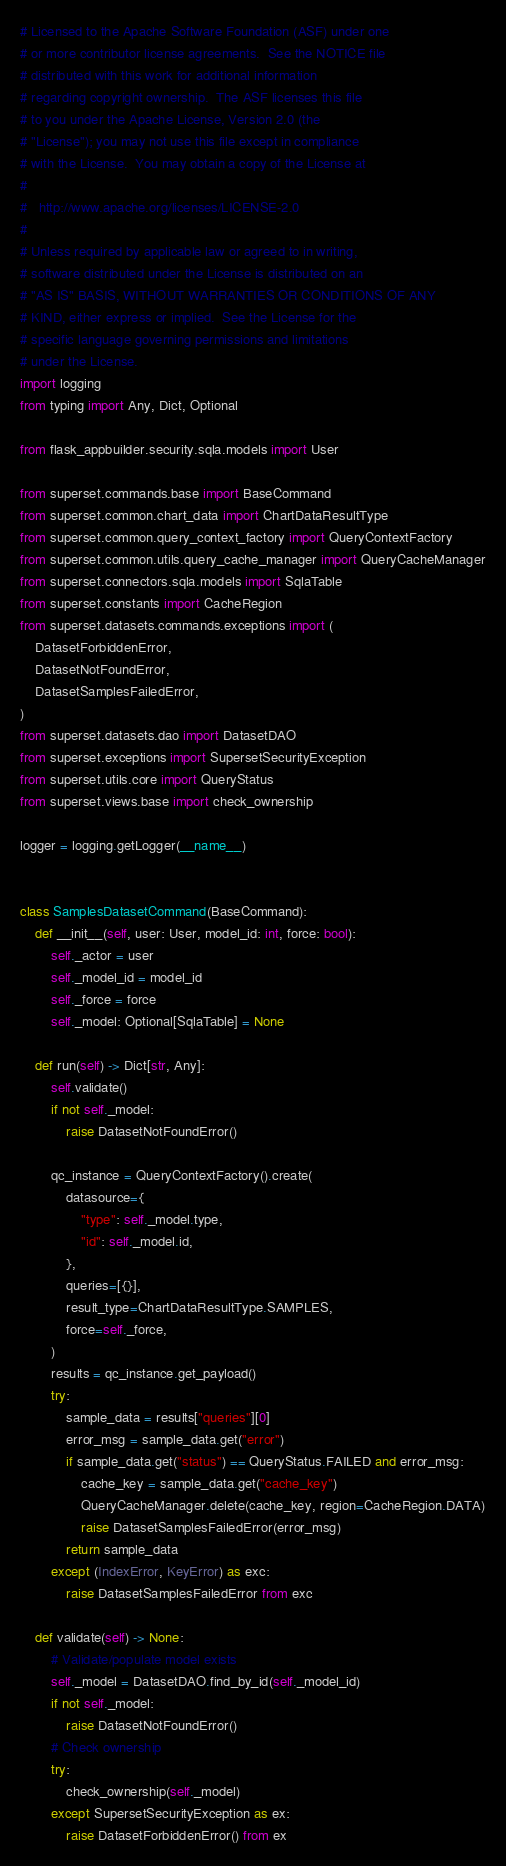Convert code to text. <code><loc_0><loc_0><loc_500><loc_500><_Python_># Licensed to the Apache Software Foundation (ASF) under one
# or more contributor license agreements.  See the NOTICE file
# distributed with this work for additional information
# regarding copyright ownership.  The ASF licenses this file
# to you under the Apache License, Version 2.0 (the
# "License"); you may not use this file except in compliance
# with the License.  You may obtain a copy of the License at
#
#   http://www.apache.org/licenses/LICENSE-2.0
#
# Unless required by applicable law or agreed to in writing,
# software distributed under the License is distributed on an
# "AS IS" BASIS, WITHOUT WARRANTIES OR CONDITIONS OF ANY
# KIND, either express or implied.  See the License for the
# specific language governing permissions and limitations
# under the License.
import logging
from typing import Any, Dict, Optional

from flask_appbuilder.security.sqla.models import User

from superset.commands.base import BaseCommand
from superset.common.chart_data import ChartDataResultType
from superset.common.query_context_factory import QueryContextFactory
from superset.common.utils.query_cache_manager import QueryCacheManager
from superset.connectors.sqla.models import SqlaTable
from superset.constants import CacheRegion
from superset.datasets.commands.exceptions import (
    DatasetForbiddenError,
    DatasetNotFoundError,
    DatasetSamplesFailedError,
)
from superset.datasets.dao import DatasetDAO
from superset.exceptions import SupersetSecurityException
from superset.utils.core import QueryStatus
from superset.views.base import check_ownership

logger = logging.getLogger(__name__)


class SamplesDatasetCommand(BaseCommand):
    def __init__(self, user: User, model_id: int, force: bool):
        self._actor = user
        self._model_id = model_id
        self._force = force
        self._model: Optional[SqlaTable] = None

    def run(self) -> Dict[str, Any]:
        self.validate()
        if not self._model:
            raise DatasetNotFoundError()

        qc_instance = QueryContextFactory().create(
            datasource={
                "type": self._model.type,
                "id": self._model.id,
            },
            queries=[{}],
            result_type=ChartDataResultType.SAMPLES,
            force=self._force,
        )
        results = qc_instance.get_payload()
        try:
            sample_data = results["queries"][0]
            error_msg = sample_data.get("error")
            if sample_data.get("status") == QueryStatus.FAILED and error_msg:
                cache_key = sample_data.get("cache_key")
                QueryCacheManager.delete(cache_key, region=CacheRegion.DATA)
                raise DatasetSamplesFailedError(error_msg)
            return sample_data
        except (IndexError, KeyError) as exc:
            raise DatasetSamplesFailedError from exc

    def validate(self) -> None:
        # Validate/populate model exists
        self._model = DatasetDAO.find_by_id(self._model_id)
        if not self._model:
            raise DatasetNotFoundError()
        # Check ownership
        try:
            check_ownership(self._model)
        except SupersetSecurityException as ex:
            raise DatasetForbiddenError() from ex
</code> 